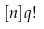<formula> <loc_0><loc_0><loc_500><loc_500>[ n ] q !</formula> 